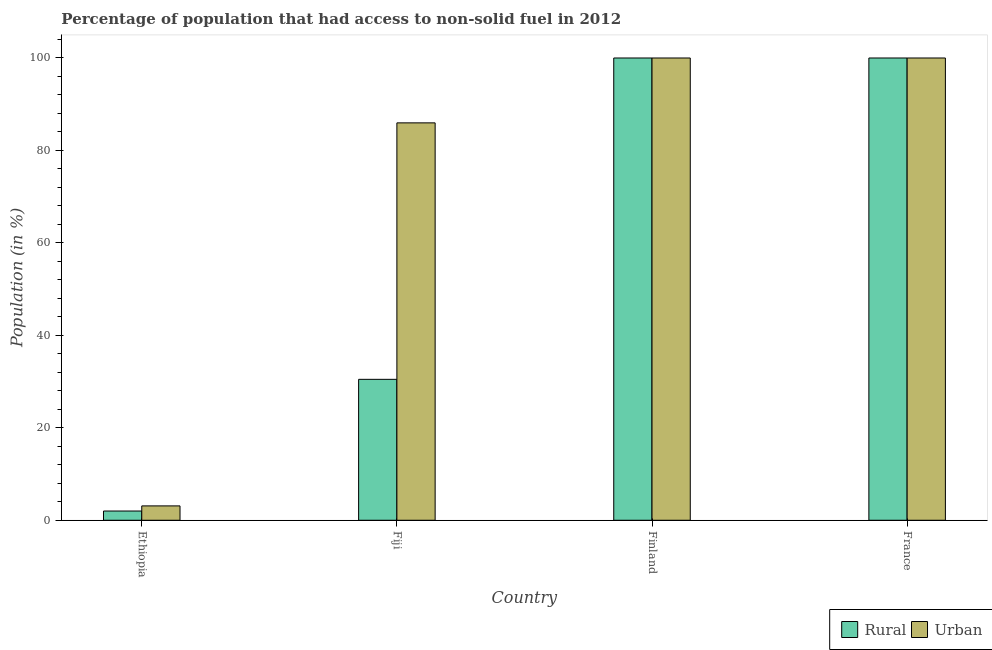How many different coloured bars are there?
Provide a short and direct response. 2. How many groups of bars are there?
Give a very brief answer. 4. How many bars are there on the 3rd tick from the left?
Provide a short and direct response. 2. In how many cases, is the number of bars for a given country not equal to the number of legend labels?
Give a very brief answer. 0. What is the rural population in Fiji?
Provide a short and direct response. 30.49. Across all countries, what is the maximum rural population?
Your answer should be compact. 100. Across all countries, what is the minimum rural population?
Offer a very short reply. 2. In which country was the rural population maximum?
Keep it short and to the point. Finland. In which country was the rural population minimum?
Make the answer very short. Ethiopia. What is the total rural population in the graph?
Offer a very short reply. 232.49. What is the difference between the urban population in Ethiopia and that in Finland?
Keep it short and to the point. -96.89. What is the difference between the urban population in Fiji and the rural population in Finland?
Your response must be concise. -14.03. What is the average urban population per country?
Offer a very short reply. 72.27. What is the difference between the rural population and urban population in Fiji?
Make the answer very short. -55.48. What is the ratio of the rural population in Ethiopia to that in France?
Give a very brief answer. 0.02. Is the urban population in Ethiopia less than that in Finland?
Give a very brief answer. Yes. Is the difference between the urban population in Ethiopia and Finland greater than the difference between the rural population in Ethiopia and Finland?
Provide a short and direct response. Yes. What is the difference between the highest and the second highest urban population?
Ensure brevity in your answer.  0. What is the difference between the highest and the lowest urban population?
Ensure brevity in your answer.  96.89. In how many countries, is the rural population greater than the average rural population taken over all countries?
Offer a very short reply. 2. What does the 2nd bar from the left in Fiji represents?
Provide a short and direct response. Urban. What does the 2nd bar from the right in Ethiopia represents?
Make the answer very short. Rural. Are all the bars in the graph horizontal?
Offer a terse response. No. Does the graph contain any zero values?
Your answer should be compact. No. How many legend labels are there?
Keep it short and to the point. 2. How are the legend labels stacked?
Ensure brevity in your answer.  Horizontal. What is the title of the graph?
Give a very brief answer. Percentage of population that had access to non-solid fuel in 2012. Does "From production" appear as one of the legend labels in the graph?
Your answer should be compact. No. What is the label or title of the X-axis?
Provide a succinct answer. Country. What is the label or title of the Y-axis?
Make the answer very short. Population (in %). What is the Population (in %) of Rural in Ethiopia?
Offer a very short reply. 2. What is the Population (in %) of Urban in Ethiopia?
Give a very brief answer. 3.11. What is the Population (in %) in Rural in Fiji?
Ensure brevity in your answer.  30.49. What is the Population (in %) in Urban in Fiji?
Offer a very short reply. 85.97. What is the Population (in %) in Urban in Finland?
Your answer should be compact. 100. What is the Population (in %) in Rural in France?
Offer a very short reply. 100. Across all countries, what is the maximum Population (in %) in Urban?
Your answer should be compact. 100. Across all countries, what is the minimum Population (in %) of Rural?
Give a very brief answer. 2. Across all countries, what is the minimum Population (in %) of Urban?
Provide a short and direct response. 3.11. What is the total Population (in %) in Rural in the graph?
Make the answer very short. 232.49. What is the total Population (in %) in Urban in the graph?
Ensure brevity in your answer.  289.07. What is the difference between the Population (in %) of Rural in Ethiopia and that in Fiji?
Provide a succinct answer. -28.49. What is the difference between the Population (in %) of Urban in Ethiopia and that in Fiji?
Your answer should be very brief. -82.86. What is the difference between the Population (in %) of Rural in Ethiopia and that in Finland?
Ensure brevity in your answer.  -98. What is the difference between the Population (in %) in Urban in Ethiopia and that in Finland?
Give a very brief answer. -96.89. What is the difference between the Population (in %) in Rural in Ethiopia and that in France?
Keep it short and to the point. -98. What is the difference between the Population (in %) in Urban in Ethiopia and that in France?
Give a very brief answer. -96.89. What is the difference between the Population (in %) in Rural in Fiji and that in Finland?
Offer a very short reply. -69.51. What is the difference between the Population (in %) of Urban in Fiji and that in Finland?
Make the answer very short. -14.03. What is the difference between the Population (in %) in Rural in Fiji and that in France?
Your answer should be very brief. -69.51. What is the difference between the Population (in %) in Urban in Fiji and that in France?
Give a very brief answer. -14.03. What is the difference between the Population (in %) in Rural in Finland and that in France?
Your answer should be very brief. 0. What is the difference between the Population (in %) of Urban in Finland and that in France?
Your answer should be very brief. 0. What is the difference between the Population (in %) of Rural in Ethiopia and the Population (in %) of Urban in Fiji?
Offer a terse response. -83.97. What is the difference between the Population (in %) in Rural in Ethiopia and the Population (in %) in Urban in Finland?
Ensure brevity in your answer.  -98. What is the difference between the Population (in %) in Rural in Ethiopia and the Population (in %) in Urban in France?
Your answer should be very brief. -98. What is the difference between the Population (in %) in Rural in Fiji and the Population (in %) in Urban in Finland?
Your answer should be very brief. -69.51. What is the difference between the Population (in %) of Rural in Fiji and the Population (in %) of Urban in France?
Provide a short and direct response. -69.51. What is the average Population (in %) in Rural per country?
Provide a succinct answer. 58.12. What is the average Population (in %) of Urban per country?
Your answer should be compact. 72.27. What is the difference between the Population (in %) of Rural and Population (in %) of Urban in Ethiopia?
Offer a very short reply. -1.11. What is the difference between the Population (in %) in Rural and Population (in %) in Urban in Fiji?
Your answer should be very brief. -55.48. What is the difference between the Population (in %) of Rural and Population (in %) of Urban in Finland?
Provide a succinct answer. 0. What is the difference between the Population (in %) of Rural and Population (in %) of Urban in France?
Your answer should be compact. 0. What is the ratio of the Population (in %) in Rural in Ethiopia to that in Fiji?
Offer a terse response. 0.07. What is the ratio of the Population (in %) of Urban in Ethiopia to that in Fiji?
Provide a short and direct response. 0.04. What is the ratio of the Population (in %) in Rural in Ethiopia to that in Finland?
Give a very brief answer. 0.02. What is the ratio of the Population (in %) in Urban in Ethiopia to that in Finland?
Keep it short and to the point. 0.03. What is the ratio of the Population (in %) in Urban in Ethiopia to that in France?
Offer a terse response. 0.03. What is the ratio of the Population (in %) in Rural in Fiji to that in Finland?
Offer a terse response. 0.3. What is the ratio of the Population (in %) of Urban in Fiji to that in Finland?
Provide a short and direct response. 0.86. What is the ratio of the Population (in %) in Rural in Fiji to that in France?
Keep it short and to the point. 0.3. What is the ratio of the Population (in %) in Urban in Fiji to that in France?
Provide a short and direct response. 0.86. What is the ratio of the Population (in %) in Rural in Finland to that in France?
Provide a succinct answer. 1. What is the ratio of the Population (in %) in Urban in Finland to that in France?
Offer a very short reply. 1. What is the difference between the highest and the second highest Population (in %) in Rural?
Your answer should be very brief. 0. What is the difference between the highest and the second highest Population (in %) of Urban?
Offer a very short reply. 0. What is the difference between the highest and the lowest Population (in %) of Rural?
Provide a short and direct response. 98. What is the difference between the highest and the lowest Population (in %) of Urban?
Keep it short and to the point. 96.89. 